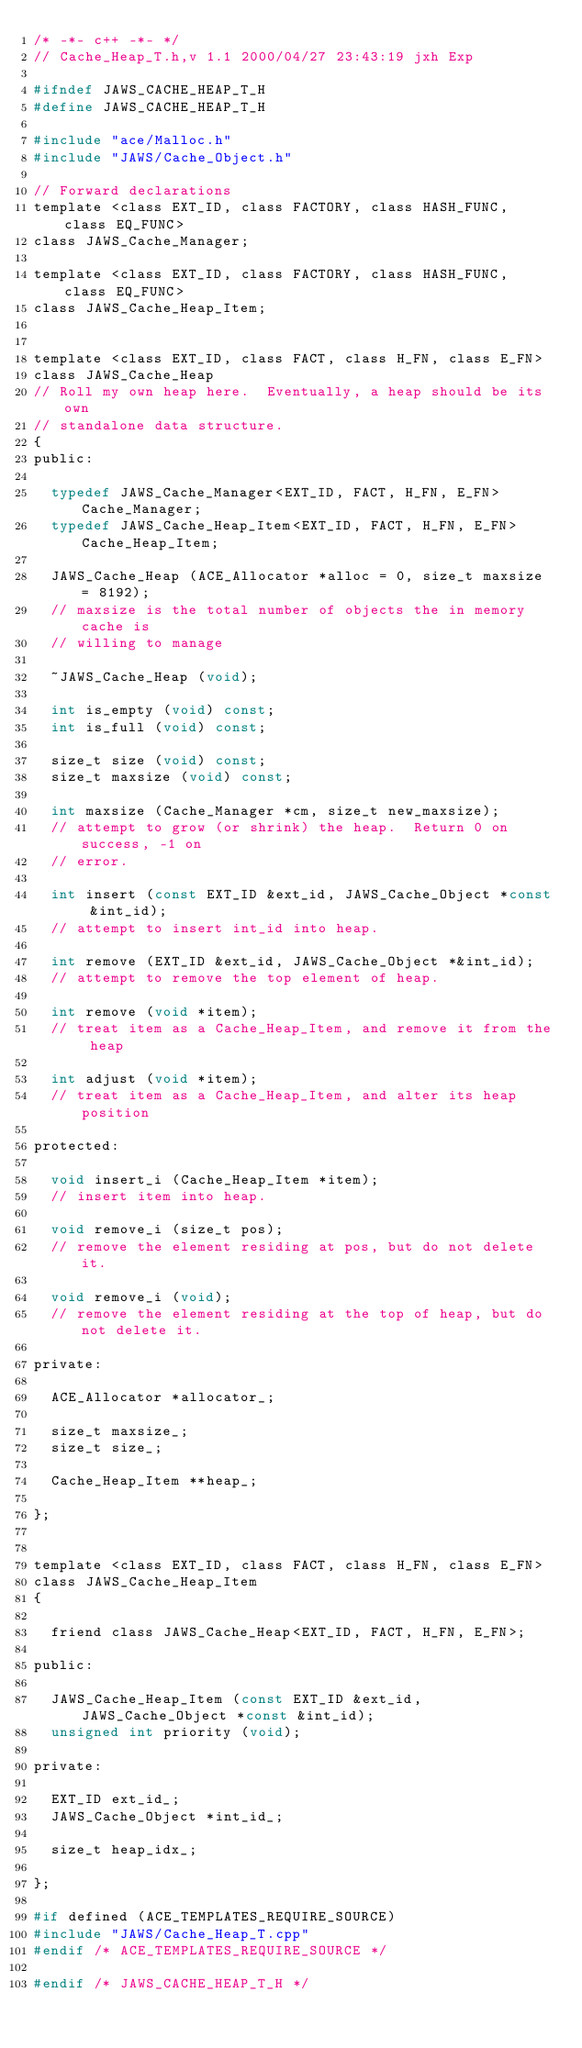<code> <loc_0><loc_0><loc_500><loc_500><_C_>/* -*- c++ -*- */
// Cache_Heap_T.h,v 1.1 2000/04/27 23:43:19 jxh Exp

#ifndef JAWS_CACHE_HEAP_T_H
#define JAWS_CACHE_HEAP_T_H

#include "ace/Malloc.h"
#include "JAWS/Cache_Object.h"

// Forward declarations
template <class EXT_ID, class FACTORY, class HASH_FUNC, class EQ_FUNC>
class JAWS_Cache_Manager;

template <class EXT_ID, class FACTORY, class HASH_FUNC, class EQ_FUNC>
class JAWS_Cache_Heap_Item;


template <class EXT_ID, class FACT, class H_FN, class E_FN>
class JAWS_Cache_Heap
// Roll my own heap here.  Eventually, a heap should be its own
// standalone data structure.
{
public:

  typedef JAWS_Cache_Manager<EXT_ID, FACT, H_FN, E_FN> Cache_Manager;
  typedef JAWS_Cache_Heap_Item<EXT_ID, FACT, H_FN, E_FN> Cache_Heap_Item;

  JAWS_Cache_Heap (ACE_Allocator *alloc = 0, size_t maxsize = 8192);
  // maxsize is the total number of objects the in memory cache is
  // willing to manage

  ~JAWS_Cache_Heap (void);

  int is_empty (void) const;
  int is_full (void) const;

  size_t size (void) const;
  size_t maxsize (void) const;

  int maxsize (Cache_Manager *cm, size_t new_maxsize);
  // attempt to grow (or shrink) the heap.  Return 0 on success, -1 on
  // error.

  int insert (const EXT_ID &ext_id, JAWS_Cache_Object *const &int_id);
  // attempt to insert int_id into heap.

  int remove (EXT_ID &ext_id, JAWS_Cache_Object *&int_id);
  // attempt to remove the top element of heap.

  int remove (void *item);
  // treat item as a Cache_Heap_Item, and remove it from the heap

  int adjust (void *item);
  // treat item as a Cache_Heap_Item, and alter its heap position

protected:

  void insert_i (Cache_Heap_Item *item);
  // insert item into heap.

  void remove_i (size_t pos);
  // remove the element residing at pos, but do not delete it.

  void remove_i (void);
  // remove the element residing at the top of heap, but do not delete it.

private:

  ACE_Allocator *allocator_;

  size_t maxsize_;
  size_t size_;

  Cache_Heap_Item **heap_;

};


template <class EXT_ID, class FACT, class H_FN, class E_FN>
class JAWS_Cache_Heap_Item
{

  friend class JAWS_Cache_Heap<EXT_ID, FACT, H_FN, E_FN>;

public:

  JAWS_Cache_Heap_Item (const EXT_ID &ext_id, JAWS_Cache_Object *const &int_id);
  unsigned int priority (void);

private:

  EXT_ID ext_id_;
  JAWS_Cache_Object *int_id_;

  size_t heap_idx_;

};

#if defined (ACE_TEMPLATES_REQUIRE_SOURCE)
#include "JAWS/Cache_Heap_T.cpp"
#endif /* ACE_TEMPLATES_REQUIRE_SOURCE */

#endif /* JAWS_CACHE_HEAP_T_H */
</code> 